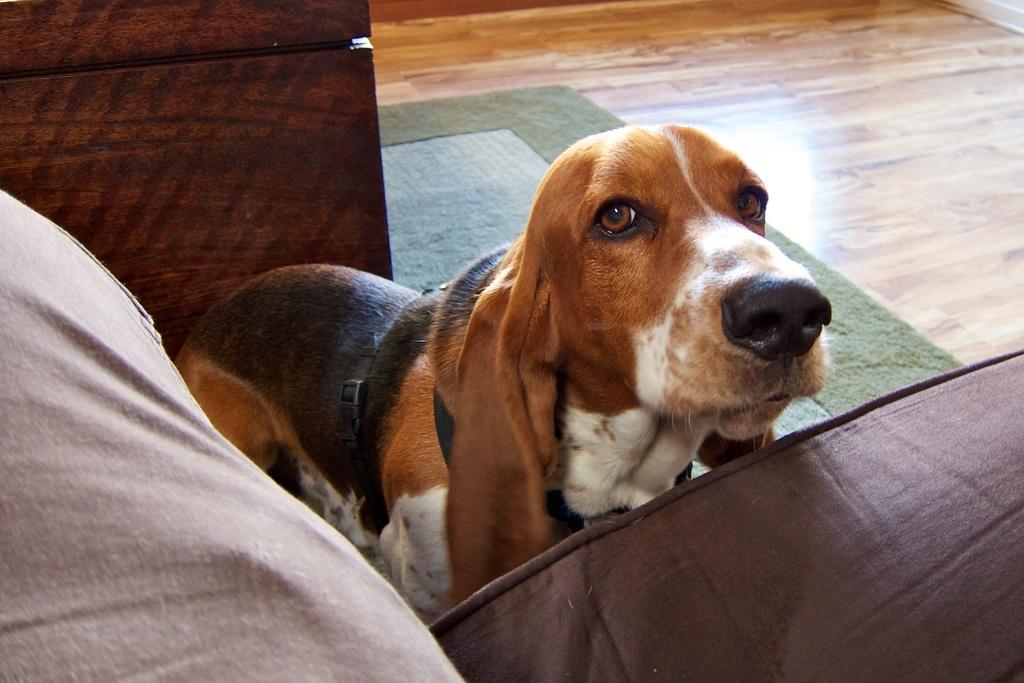Describe this image in one or two sentences. In this picture there is a person sitting on the sofa and there is a dog standing. At the back there is a wooden object. At the bottom there is a floor and there is a mat. 